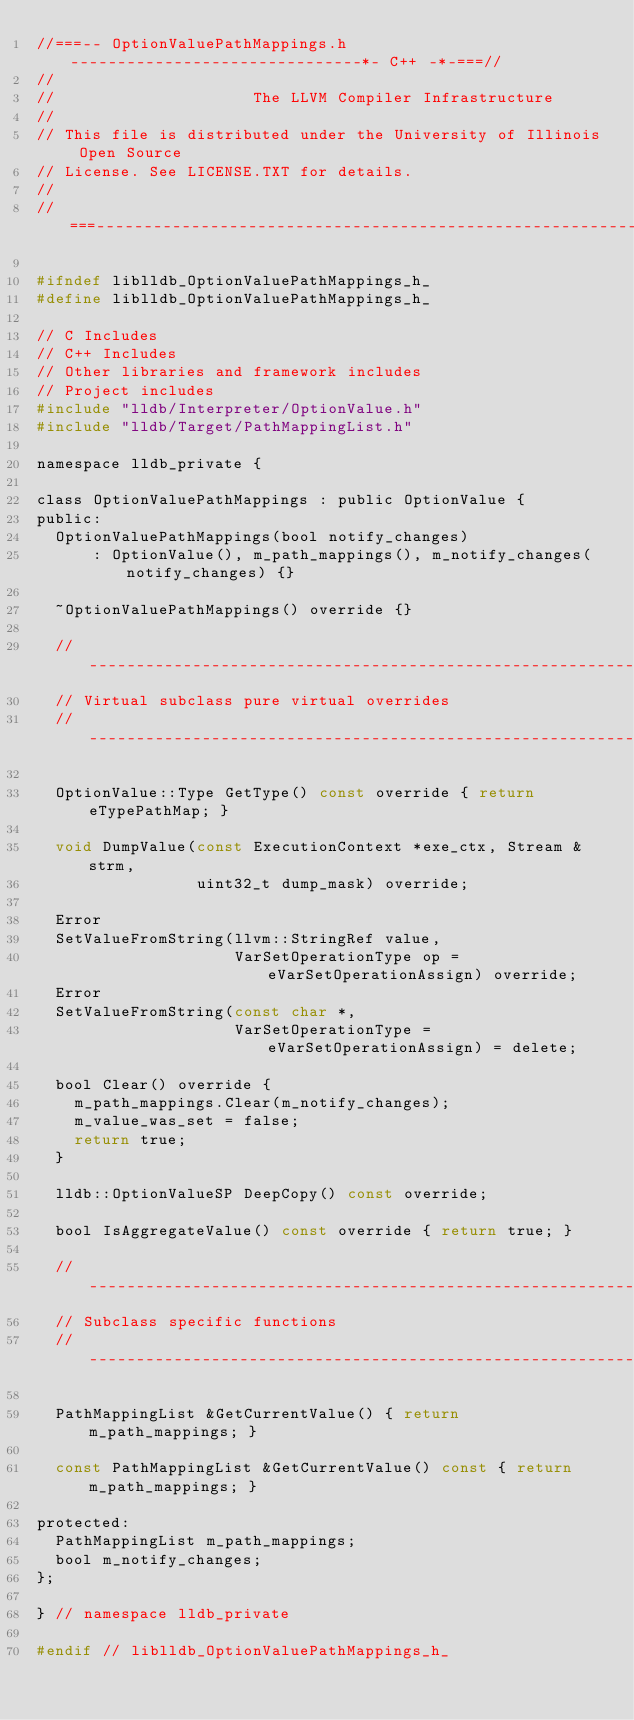<code> <loc_0><loc_0><loc_500><loc_500><_C_>//===-- OptionValuePathMappings.h -------------------------------*- C++ -*-===//
//
//                     The LLVM Compiler Infrastructure
//
// This file is distributed under the University of Illinois Open Source
// License. See LICENSE.TXT for details.
//
//===----------------------------------------------------------------------===//

#ifndef liblldb_OptionValuePathMappings_h_
#define liblldb_OptionValuePathMappings_h_

// C Includes
// C++ Includes
// Other libraries and framework includes
// Project includes
#include "lldb/Interpreter/OptionValue.h"
#include "lldb/Target/PathMappingList.h"

namespace lldb_private {

class OptionValuePathMappings : public OptionValue {
public:
  OptionValuePathMappings(bool notify_changes)
      : OptionValue(), m_path_mappings(), m_notify_changes(notify_changes) {}

  ~OptionValuePathMappings() override {}

  //---------------------------------------------------------------------
  // Virtual subclass pure virtual overrides
  //---------------------------------------------------------------------

  OptionValue::Type GetType() const override { return eTypePathMap; }

  void DumpValue(const ExecutionContext *exe_ctx, Stream &strm,
                 uint32_t dump_mask) override;

  Error
  SetValueFromString(llvm::StringRef value,
                     VarSetOperationType op = eVarSetOperationAssign) override;
  Error
  SetValueFromString(const char *,
                     VarSetOperationType = eVarSetOperationAssign) = delete;

  bool Clear() override {
    m_path_mappings.Clear(m_notify_changes);
    m_value_was_set = false;
    return true;
  }

  lldb::OptionValueSP DeepCopy() const override;

  bool IsAggregateValue() const override { return true; }

  //---------------------------------------------------------------------
  // Subclass specific functions
  //---------------------------------------------------------------------

  PathMappingList &GetCurrentValue() { return m_path_mappings; }

  const PathMappingList &GetCurrentValue() const { return m_path_mappings; }

protected:
  PathMappingList m_path_mappings;
  bool m_notify_changes;
};

} // namespace lldb_private

#endif // liblldb_OptionValuePathMappings_h_
</code> 